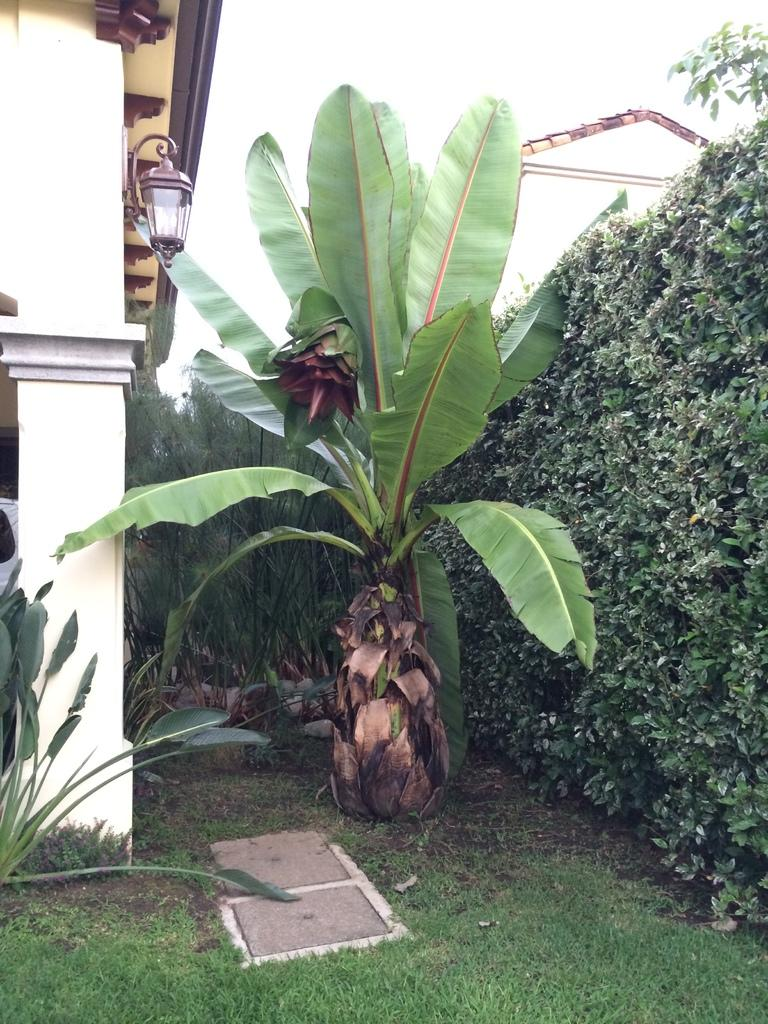What type of vegetation can be seen in the image? There are plants and grass in the image. What type of infrastructure is visible in the image? The lids of the manhole, a building with pillars, and a house with a roof are visible in the image. What type of lighting is present in the image? A lamp is present in the image. What is the condition of the sky in the image? The sky is visible in the image and appears cloudy. How many pizzas are being delivered to the house in the image? There are no pizzas or delivery in the image; it features plants, grass, manhole lids, a building with pillars, a lamp, and a house with a roof. What part of the house is being renovated in the image? There is no indication of any renovation or construction work in the image. 